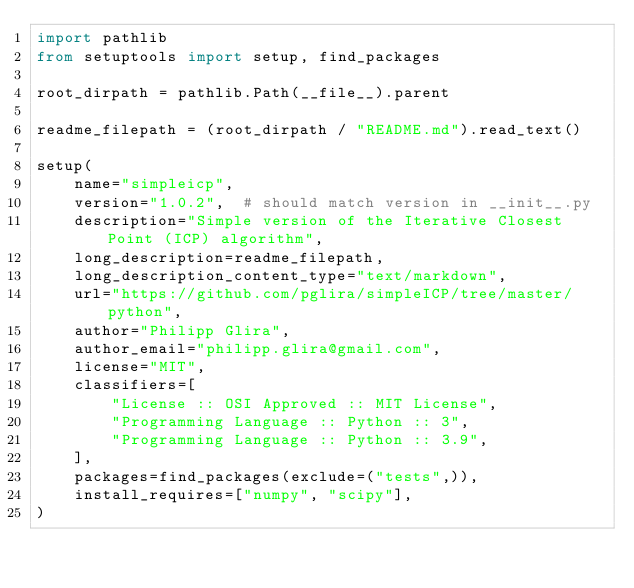Convert code to text. <code><loc_0><loc_0><loc_500><loc_500><_Python_>import pathlib
from setuptools import setup, find_packages

root_dirpath = pathlib.Path(__file__).parent

readme_filepath = (root_dirpath / "README.md").read_text()

setup(
    name="simpleicp",
    version="1.0.2",  # should match version in __init__.py
    description="Simple version of the Iterative Closest Point (ICP) algorithm",
    long_description=readme_filepath,
    long_description_content_type="text/markdown",
    url="https://github.com/pglira/simpleICP/tree/master/python",
    author="Philipp Glira",
    author_email="philipp.glira@gmail.com",
    license="MIT",
    classifiers=[
        "License :: OSI Approved :: MIT License",
        "Programming Language :: Python :: 3",
        "Programming Language :: Python :: 3.9",
    ],
    packages=find_packages(exclude=("tests",)),
    install_requires=["numpy", "scipy"],
)
</code> 